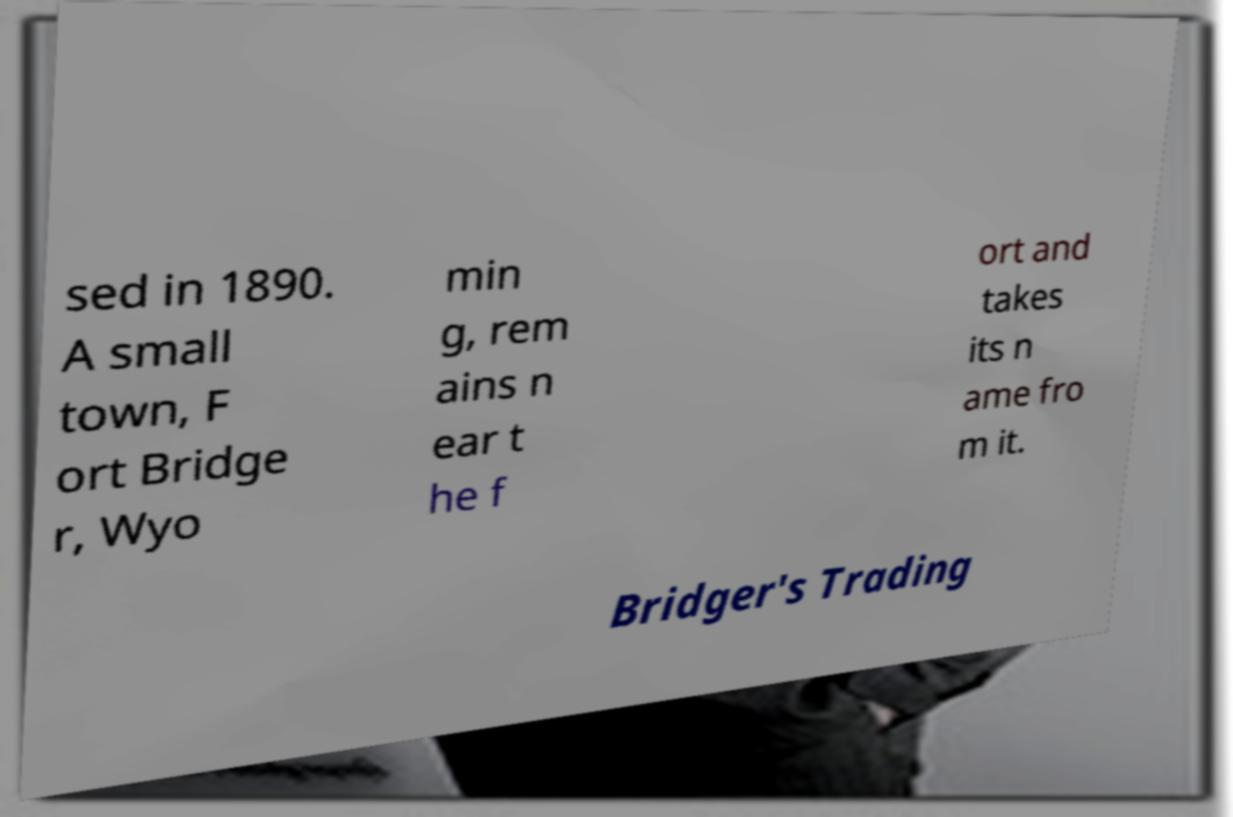What messages or text are displayed in this image? I need them in a readable, typed format. sed in 1890. A small town, F ort Bridge r, Wyo min g, rem ains n ear t he f ort and takes its n ame fro m it. Bridger's Trading 